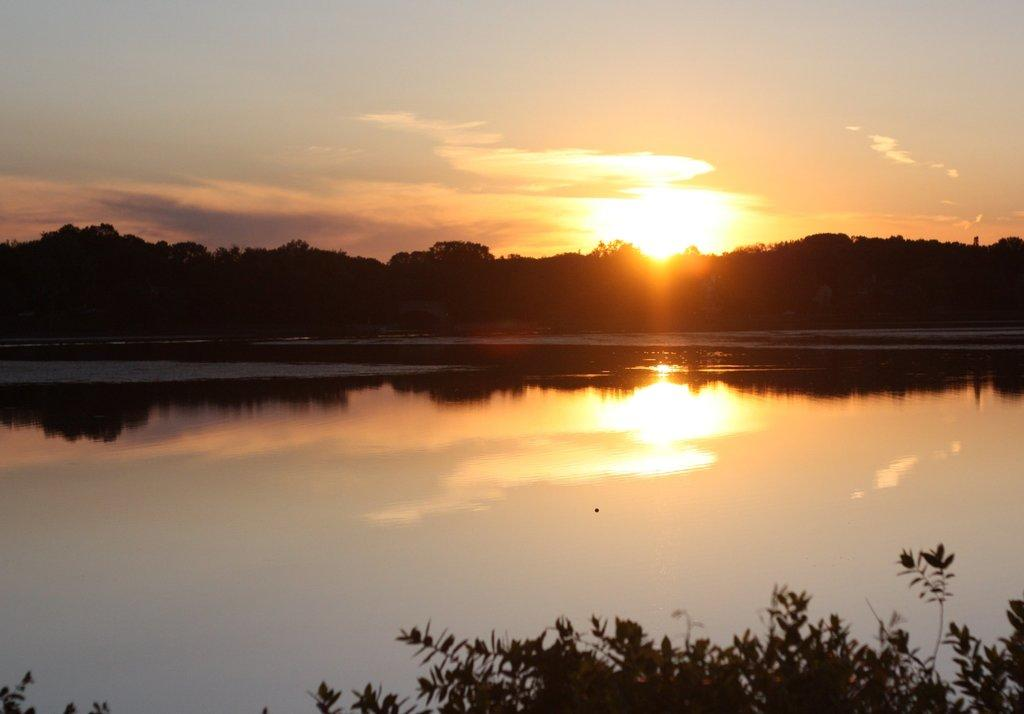What can be seen in the sky in the image? The sky is visible in the image, and there are clouds and the sun in the sky. What type of natural environment is depicted in the image? The image features trees, a lake, and plants, which are all elements of a natural environment. Can you describe the weather conditions in the image? The presence of clouds and the sun suggests partly cloudy weather conditions. What authority figure can be seen in the image? There is no authority figure present in the image. What riddle is depicted in the image? There is no riddle depicted in the image; it features natural elements such as the sky, clouds, sun, trees, lake, and plants. 